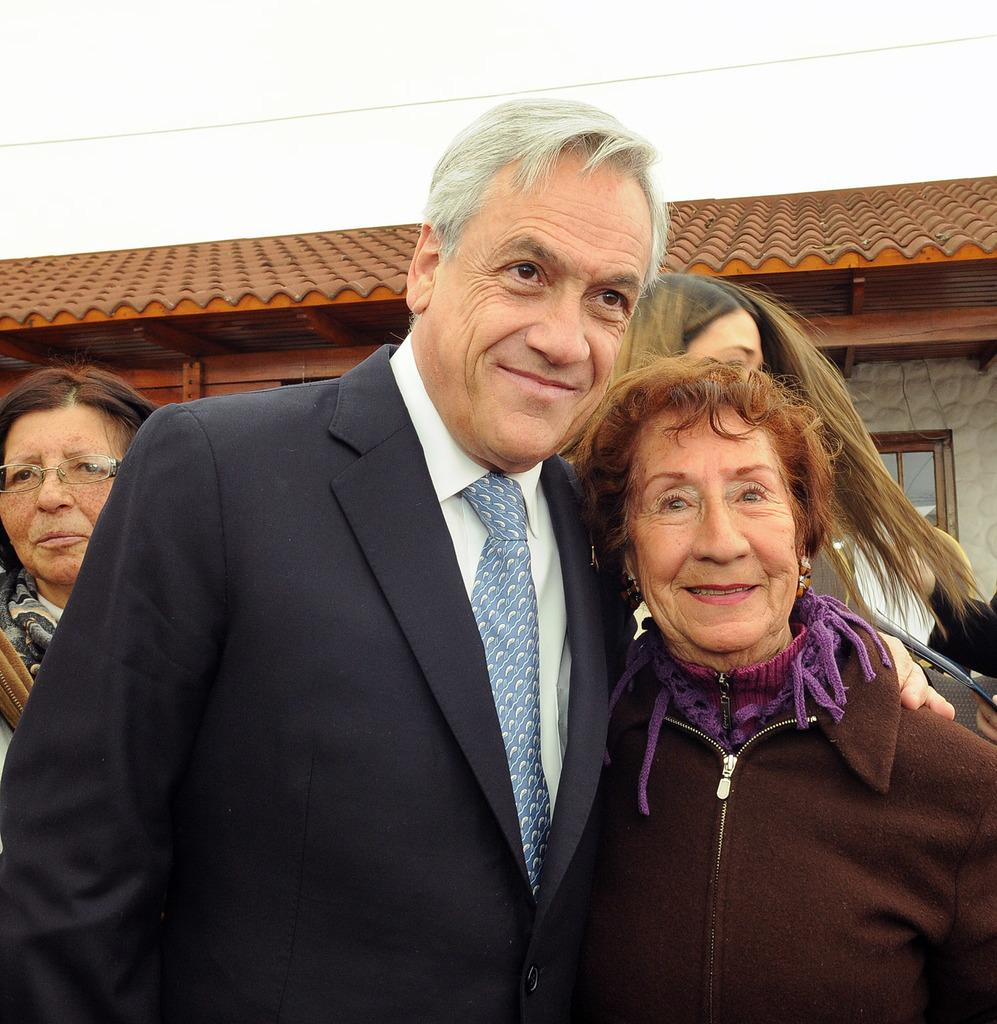What is happening in the image? There is a group of people standing in the image. What can be seen in the background of the image? There is a house with a roof and windows, a wire, and the sky visible in the background. What type of store can be seen in the image? There is no store present in the image. Can you describe the waves in the image? There are no waves present in the image. 